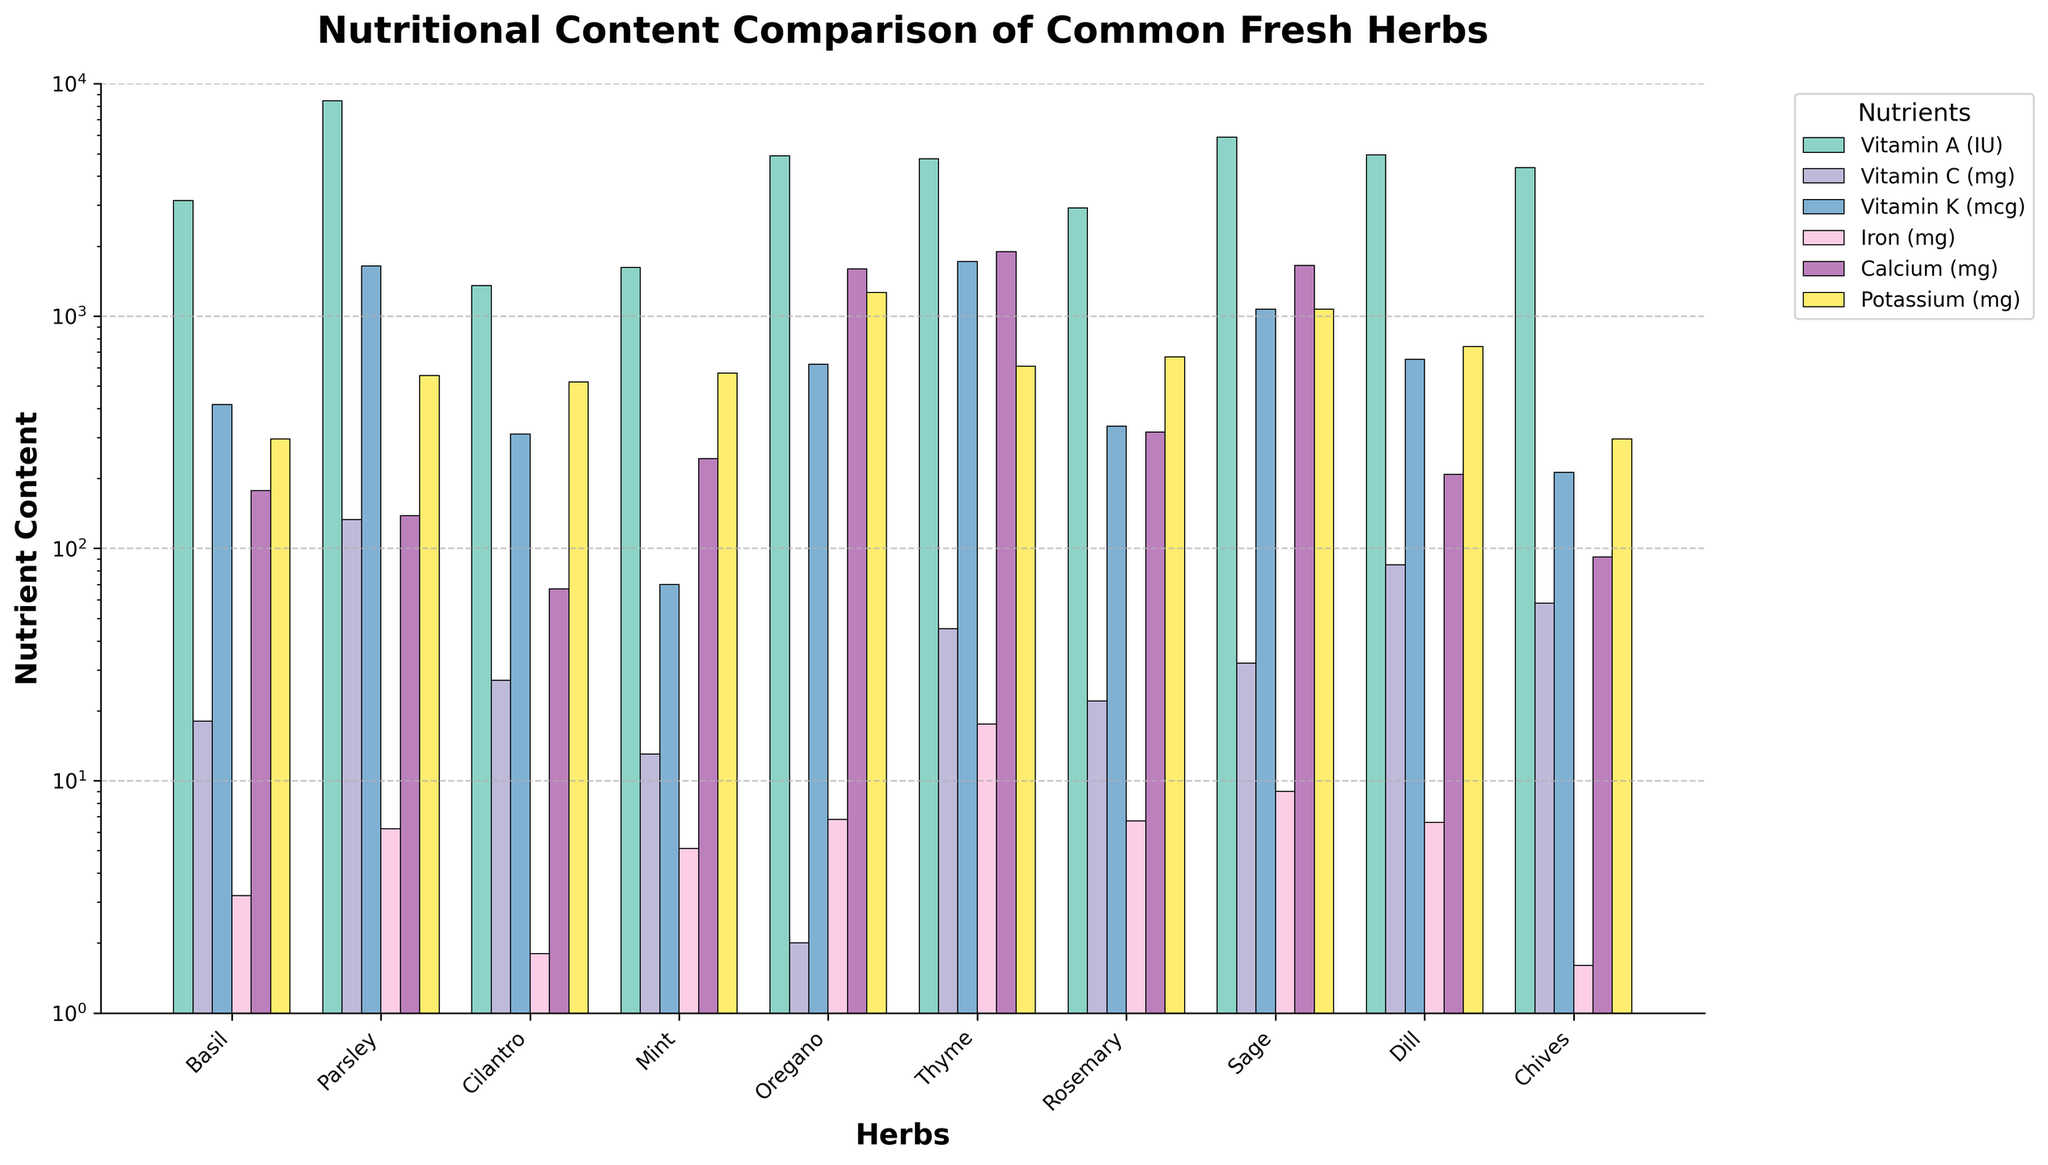Which herb has the highest Vitamin A content? First, identify the bar associated with Vitamin A for each herb, then look for the tallest bar among them. Parsley has the tallest Vitamin A bar.
Answer: Parsley Which herb contains the least amount of Calcium? Examine all the bars representing Calcium for each herb, and find the shortest bar, which corresponds to Cilantro.
Answer: Cilantro How does the Iron content of Rosemary compare to that of Basil? Look at the Iron bars for both Rosemary and Basil. Rosemary's bar is clearly taller than Basil's.
Answer: Rosemary has more Iron than Basil What is the total Potassium content of Parsley and Mint? Locate the Potassium bars for Parsley and Mint, note their heights, and sum their values: Parsley (554) + Mint (569) = 1123.
Answer: 1123 Which herb has the most balanced distribution of the nutrients? Balance can be inferred by examining the relative heights of all nutrient bars for each herb. Parsley shows relatively high values across all nutrients with fewer extreme peaks and troughs.
Answer: Parsley What is the difference in Vitamin C content between Dill and Oregano? Identify the Vitamin C bars for Dill (85 mg) and Oregano (2 mg), then subtract the smaller value from the larger value: 85 - 2 = 83 mg.
Answer: 83 mg Which herb has the highest amount of Vitamin K? Find the tallest bar in the Vitamin K segment, which corresponds to Parsley.
Answer: Parsley Estimate the average Vitamin A content for all herbs. Sum the Vitamin A values for all herbs (3142 + 8424 + 1350 + 1620 + 4890 + 4751 + 2924 + 5900 + 4933 + 4353) = 42287, then divide by the number of herbs (10): 42287 / 10 = 4228.7.
Answer: 4228.7 How many herbs have a Vitamin C content higher than 30 mg? Locate the Vitamin C bars and count the herbs with bars taller than 30 mg: Parsley (133), Cilantro (27), Thyme (45), Rosemary (22), Sage (32), Dill (85), Chives (58). Four herbs fit the criteria.
Answer: 4 What proportion of the herbs have lower Iron content than Sage? Sage has 9.0 mg of Iron. Count the herbs whose bars fall below this amount and divide by the total number of herbs. Cilantro (1.8), Basil (3.2), and Chives (1.6) have less Iron than Sage. Thus, 3/10 herbs have less Iron.
Answer: 0.3 or 30% 